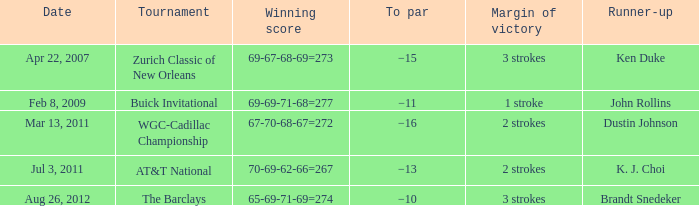Who was the runner-up in the tournament that has a margin of victory of 2 strokes, and a To par of −16? Dustin Johnson. 